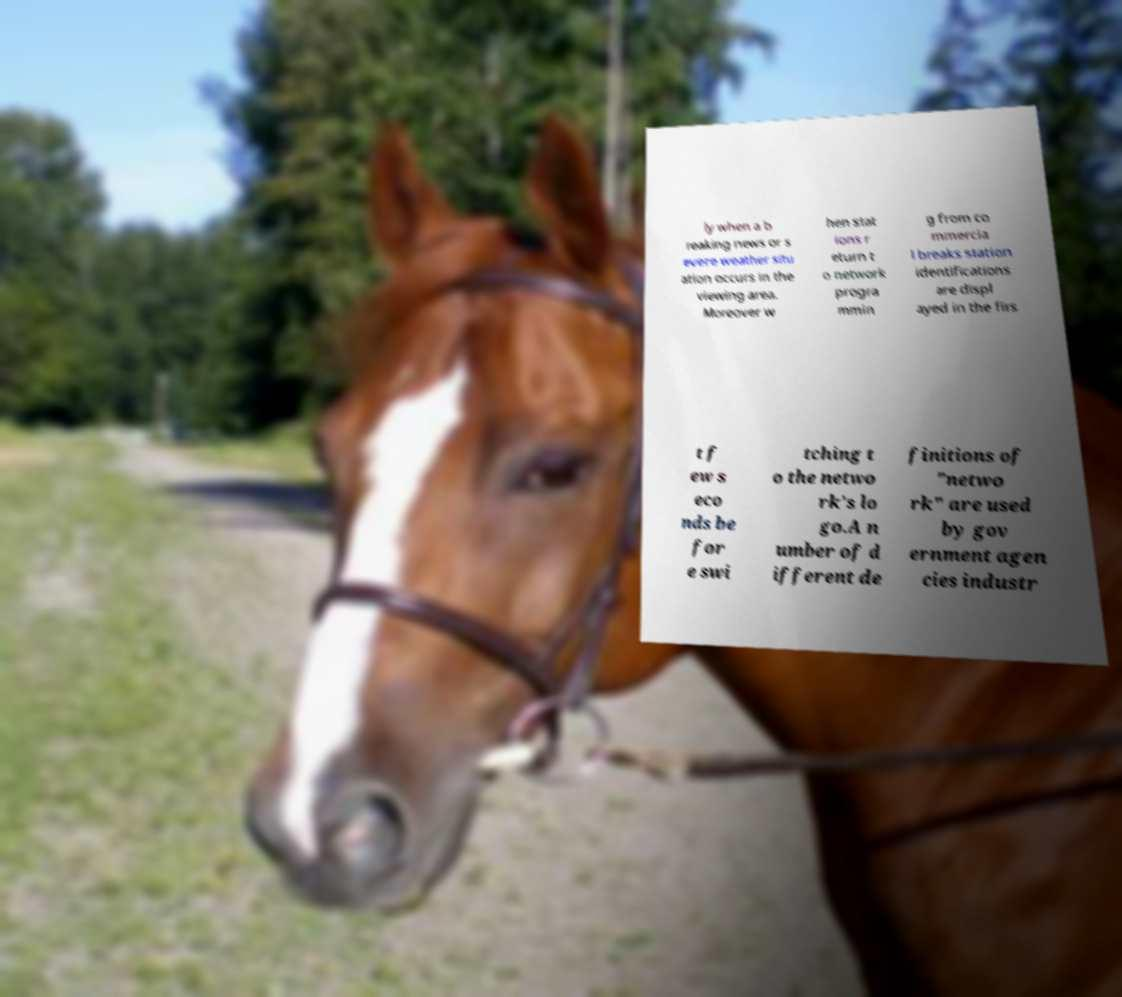Can you accurately transcribe the text from the provided image for me? ly when a b reaking news or s evere weather situ ation occurs in the viewing area. Moreover w hen stat ions r eturn t o network progra mmin g from co mmercia l breaks station identifications are displ ayed in the firs t f ew s eco nds be for e swi tching t o the netwo rk's lo go.A n umber of d ifferent de finitions of "netwo rk" are used by gov ernment agen cies industr 